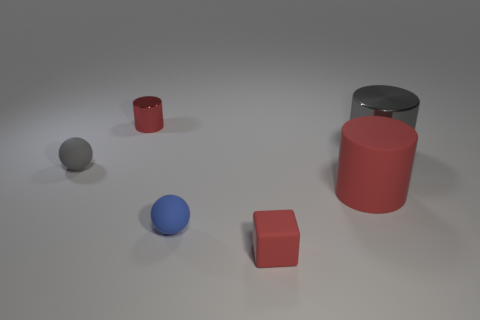Add 2 red rubber things. How many objects exist? 8 Subtract all cubes. How many objects are left? 5 Add 1 small blue objects. How many small blue objects exist? 2 Subtract 0 red balls. How many objects are left? 6 Subtract all big red cylinders. Subtract all large things. How many objects are left? 3 Add 2 tiny gray balls. How many tiny gray balls are left? 3 